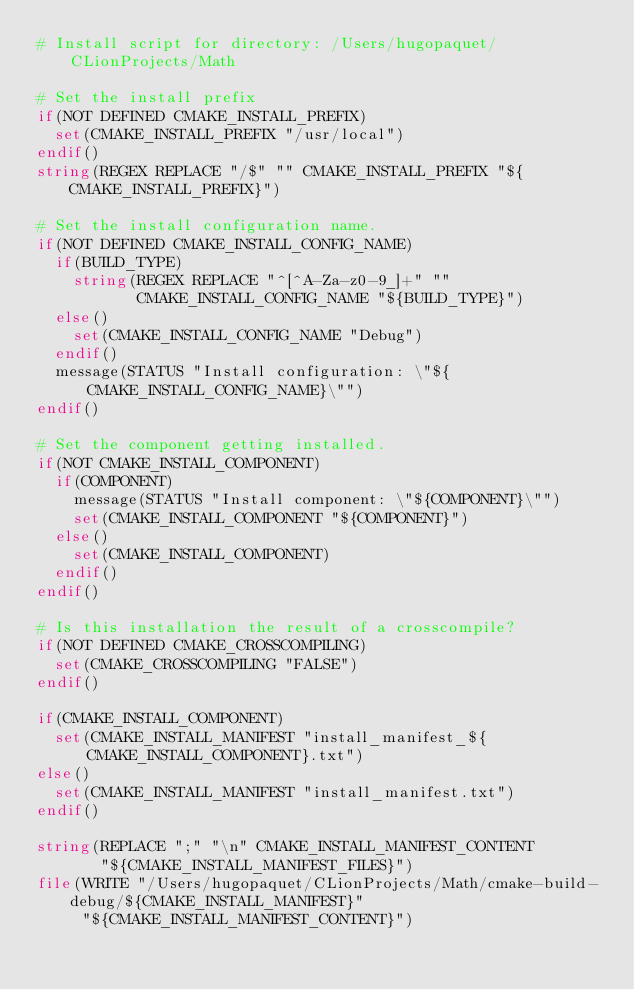Convert code to text. <code><loc_0><loc_0><loc_500><loc_500><_CMake_># Install script for directory: /Users/hugopaquet/CLionProjects/Math

# Set the install prefix
if(NOT DEFINED CMAKE_INSTALL_PREFIX)
  set(CMAKE_INSTALL_PREFIX "/usr/local")
endif()
string(REGEX REPLACE "/$" "" CMAKE_INSTALL_PREFIX "${CMAKE_INSTALL_PREFIX}")

# Set the install configuration name.
if(NOT DEFINED CMAKE_INSTALL_CONFIG_NAME)
  if(BUILD_TYPE)
    string(REGEX REPLACE "^[^A-Za-z0-9_]+" ""
           CMAKE_INSTALL_CONFIG_NAME "${BUILD_TYPE}")
  else()
    set(CMAKE_INSTALL_CONFIG_NAME "Debug")
  endif()
  message(STATUS "Install configuration: \"${CMAKE_INSTALL_CONFIG_NAME}\"")
endif()

# Set the component getting installed.
if(NOT CMAKE_INSTALL_COMPONENT)
  if(COMPONENT)
    message(STATUS "Install component: \"${COMPONENT}\"")
    set(CMAKE_INSTALL_COMPONENT "${COMPONENT}")
  else()
    set(CMAKE_INSTALL_COMPONENT)
  endif()
endif()

# Is this installation the result of a crosscompile?
if(NOT DEFINED CMAKE_CROSSCOMPILING)
  set(CMAKE_CROSSCOMPILING "FALSE")
endif()

if(CMAKE_INSTALL_COMPONENT)
  set(CMAKE_INSTALL_MANIFEST "install_manifest_${CMAKE_INSTALL_COMPONENT}.txt")
else()
  set(CMAKE_INSTALL_MANIFEST "install_manifest.txt")
endif()

string(REPLACE ";" "\n" CMAKE_INSTALL_MANIFEST_CONTENT
       "${CMAKE_INSTALL_MANIFEST_FILES}")
file(WRITE "/Users/hugopaquet/CLionProjects/Math/cmake-build-debug/${CMAKE_INSTALL_MANIFEST}"
     "${CMAKE_INSTALL_MANIFEST_CONTENT}")
</code> 